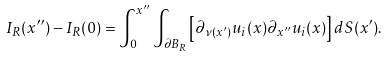<formula> <loc_0><loc_0><loc_500><loc_500>I _ { R } ( x ^ { \prime \prime } ) - I _ { R } ( 0 ) = \int _ { 0 } ^ { x ^ { \prime \prime } } \int _ { \partial B _ { R } } \left [ \partial _ { \nu ( x ^ { \prime } ) } u _ { i } ( x ) \partial _ { x ^ { \prime \prime } } u _ { i } ( x ) \right ] d S ( x ^ { \prime } ) .</formula> 